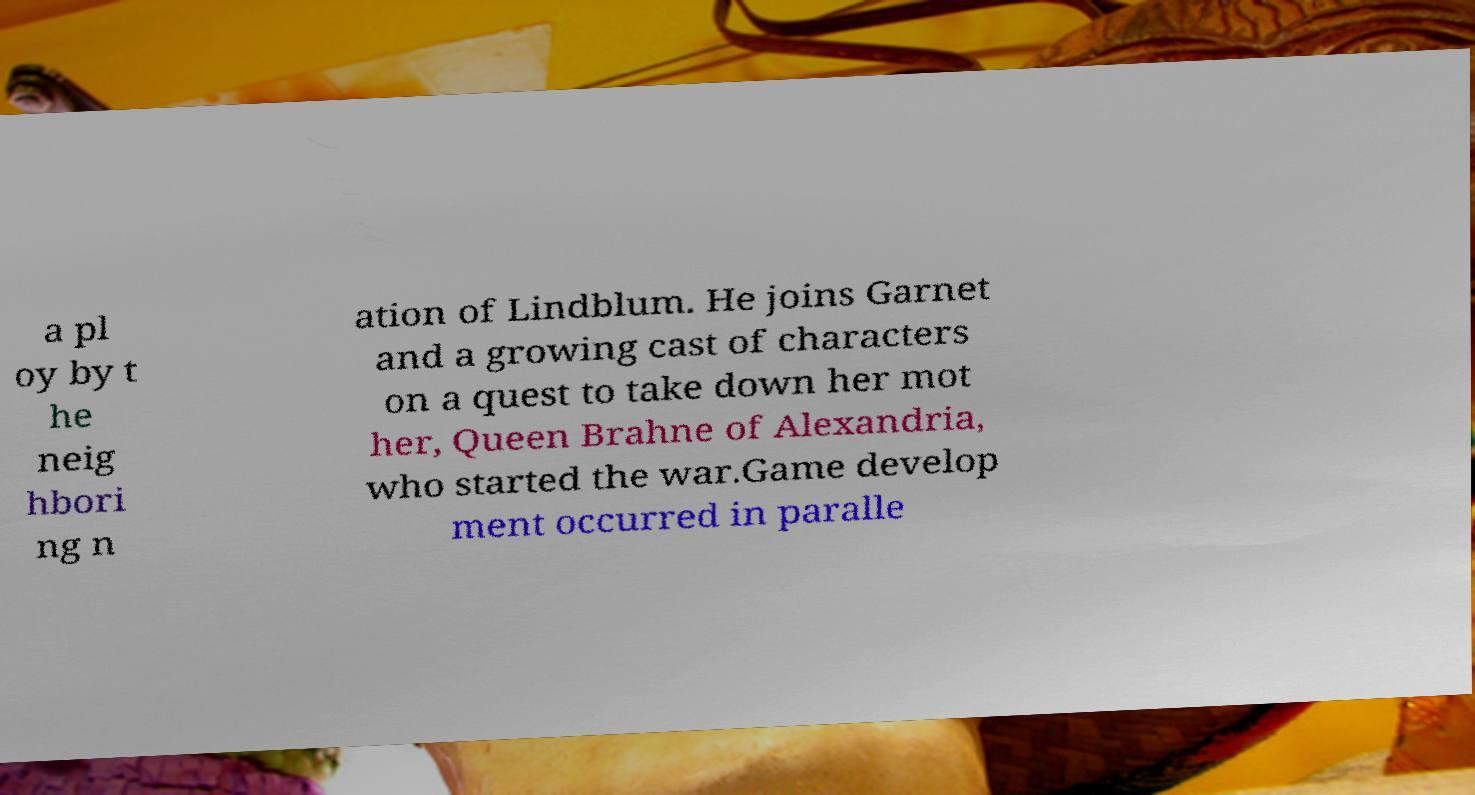There's text embedded in this image that I need extracted. Can you transcribe it verbatim? a pl oy by t he neig hbori ng n ation of Lindblum. He joins Garnet and a growing cast of characters on a quest to take down her mot her, Queen Brahne of Alexandria, who started the war.Game develop ment occurred in paralle 